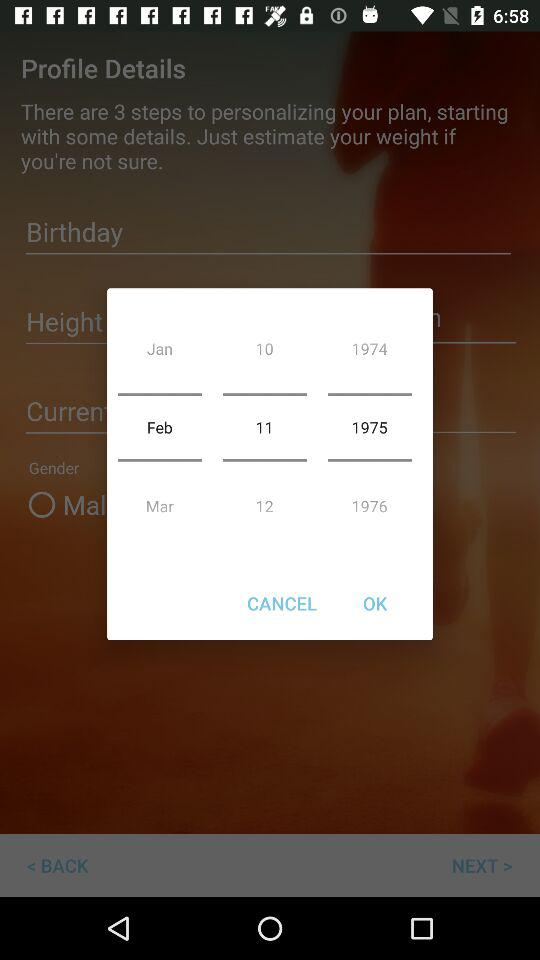How many months are displayed in the bottom row?
Answer the question using a single word or phrase. 3 